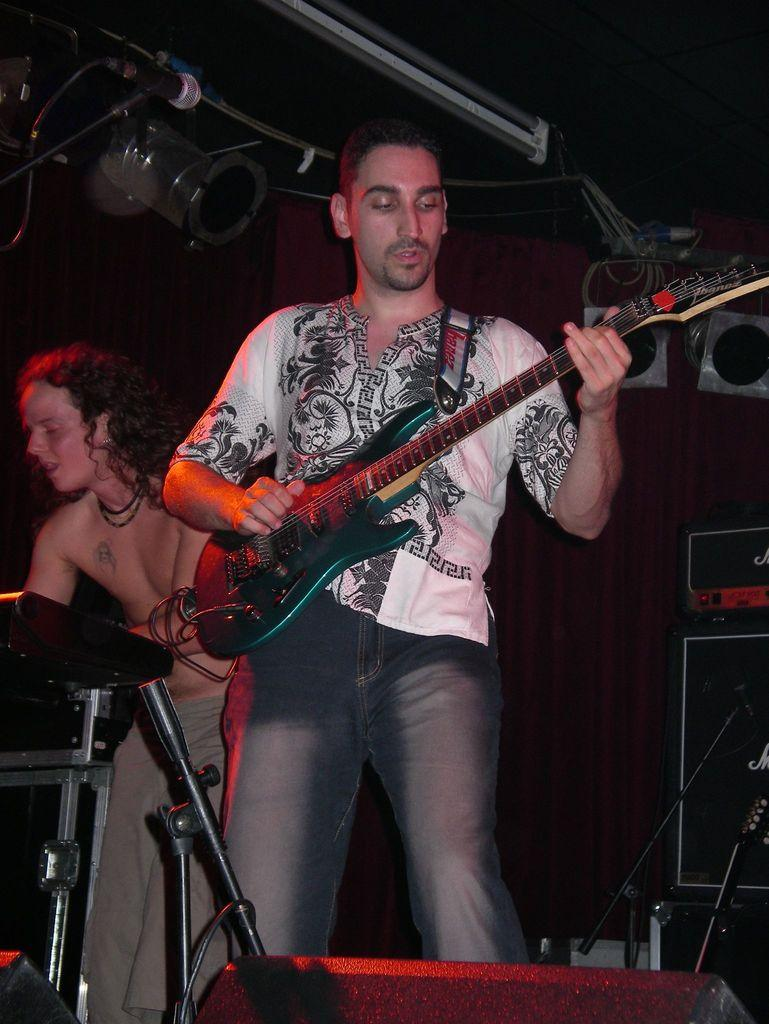What is the man in the image holding? The man is holding a guitar in the image. What is the man doing with the guitar? The man is playing the guitar in the image. What other musical instrument can be seen in the image? There is a piano being played by another person in the image. What equipment is present for amplifying sound? There are mic stands in the image. What electronic device is visible in the image? There is a radio in the image. What can be seen in the background of the image? There is a wall visible in the image. What type of ring is the man wearing on his left hand in the image? There is no mention of a ring or any jewelry in the image; the man is holding and playing a guitar. 